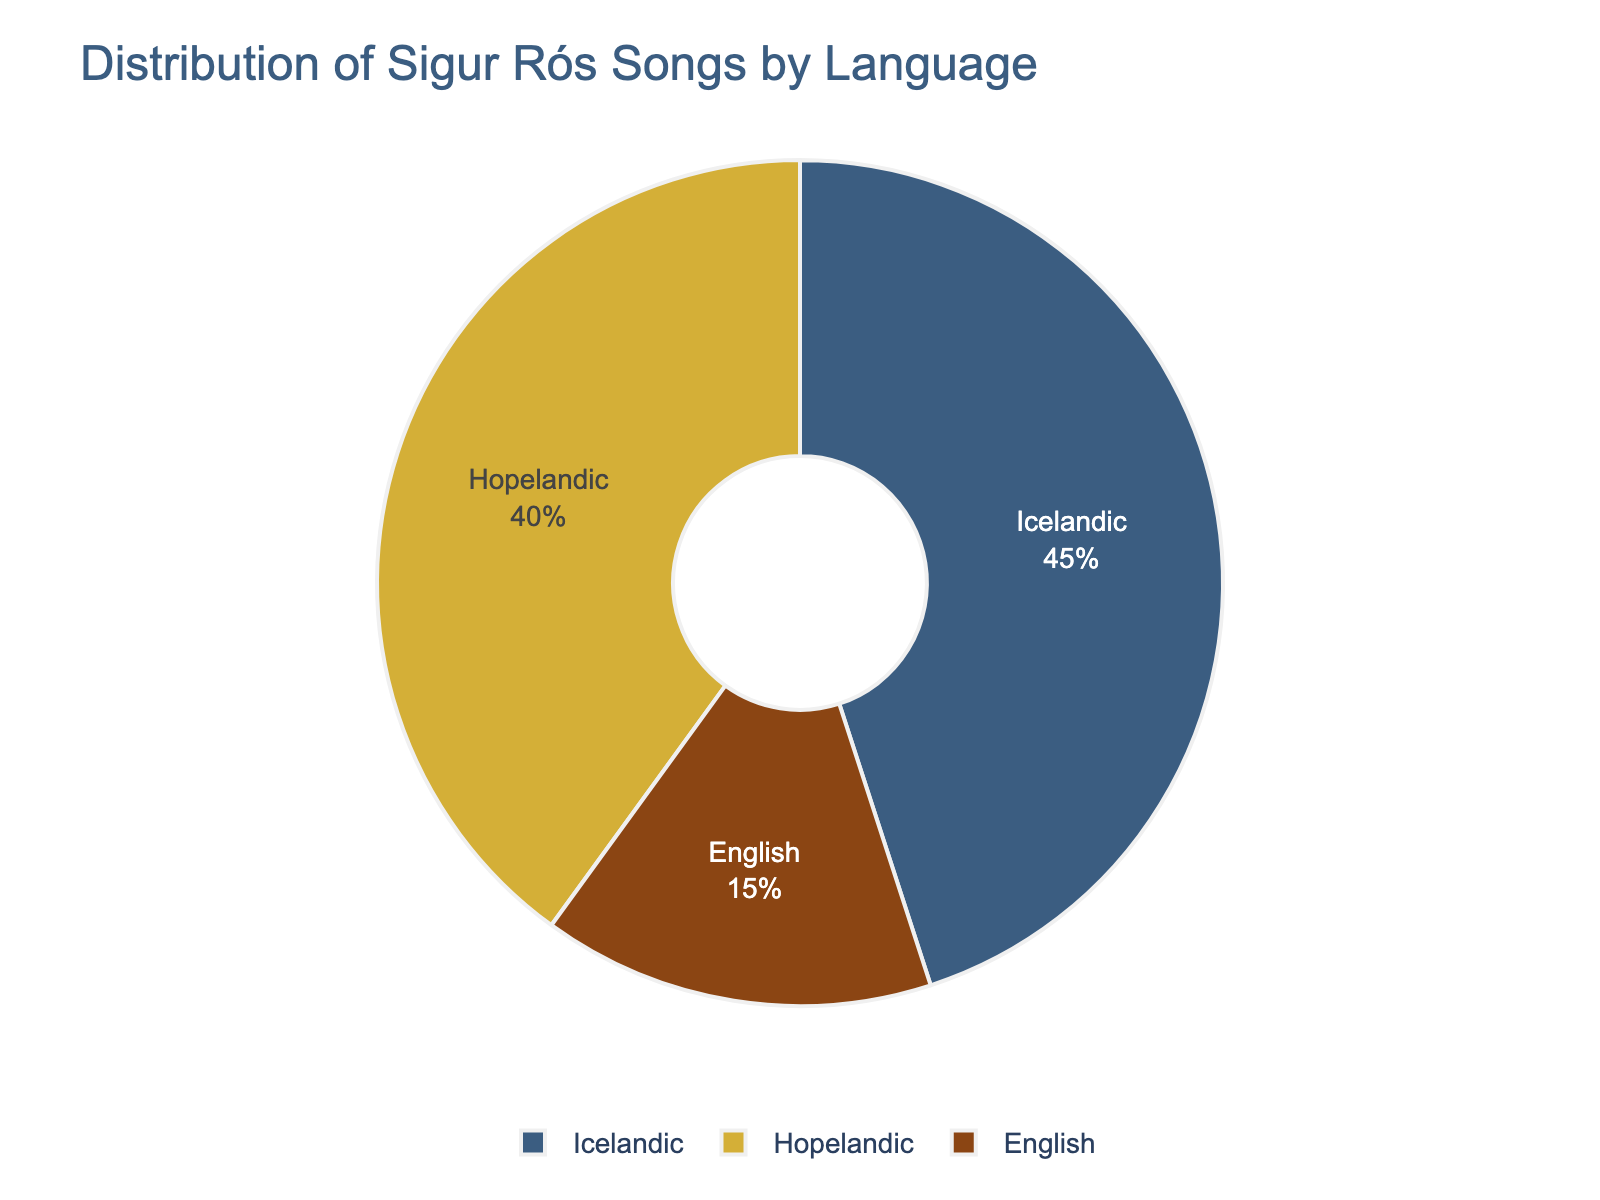Which language has the highest percentage of Sigur Rós songs? The chart shows three language categories, and Icelandic has the largest percentage slice.
Answer: Icelandic Which language has the smallest percentage of Sigur Rós songs? The chart indicates that English has the smallest percentage slice compared to Icelandic and Hopelandic.
Answer: English What is the combined percentage of Sigur Rós songs sung in Icelandic and Hopelandic? The chart shows 45% for Icelandic and 40% for Hopelandic. Adding these percentages: 45% + 40% = 85%.
Answer: 85% By how much does the percentage of Icelandic songs exceed that of English songs? The chart indicates that Icelandic songs account for 45% and English songs for 15%. Subtracting these values: 45% - 15% = 30%.
Answer: 30% Is the percentage of Hopelandic songs more or less than that of Icelandic songs? By how much? Hopelandic songs make up 40% and Icelandic songs 45%. Comparing these, Icelandic is 5% more than Hopelandic.
Answer: Less by 5% Which two languages together make up more than half of the songs? The chart shows that Icelandic is 45% and Hopelandic is 40%. Together, they sum to 85%, which is more than half.
Answer: Icelandic and Hopelandic What fraction of the songs are in Hopelandic and English combined? Hopelandic is 40% and English is 15%. Combined, 40% + 15% = 55%. This can be represented as the fraction 55/100 or 11/20.
Answer: 11/20 Compare and contrast the percentage of songs in Icelandic vs. the combined percentage of songs in English and Hopelandic. Icelandic songs are 45%. English and Hopelandic combined are 15% + 40% = 55%. Combined English and Hopelandic (55%) is higher than Icelandic (45%).
Answer: English and Hopelandic combined are higher by 10% What is the difference between the highest and the lowest percentages of songs in different languages? The chart shows 45% (Icelandic, highest) and 15% (English, lowest). The difference is: 45% - 15% = 30%.
Answer: 30% If another language category was introduced with 10% of the songs, what would the new percentage for Icelandic be? Originally, Icelandic is 45%. Introducing a new category reduces the total percentage available to 90%. The new percentage for Icelandic is calculated as: (45% / 100%) * 90% = 40.5%.
Answer: 40.5% 